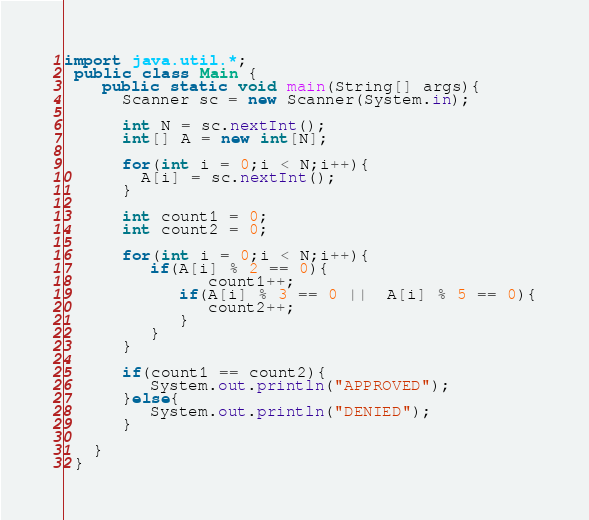Convert code to text. <code><loc_0><loc_0><loc_500><loc_500><_Java_>import java.util.*;
 public class Main {
	public static void main(String[] args){
      Scanner sc = new Scanner(System.in);

      int N = sc.nextInt();
      int[] A = new int[N];

      for(int i = 0;i < N;i++){
        A[i] = sc.nextInt();
      }

      int count1 = 0;
      int count2 = 0;
      
      for(int i = 0;i < N;i++){
         if(A[i] % 2 == 0){
               count1++;
            if(A[i] % 3 == 0 ||  A[i] % 5 == 0){
               count2++;
            }
         }
      }

      if(count1 == count2){
         System.out.println("APPROVED");
      }else{
         System.out.println("DENIED");
      }
      
   }
 }
</code> 